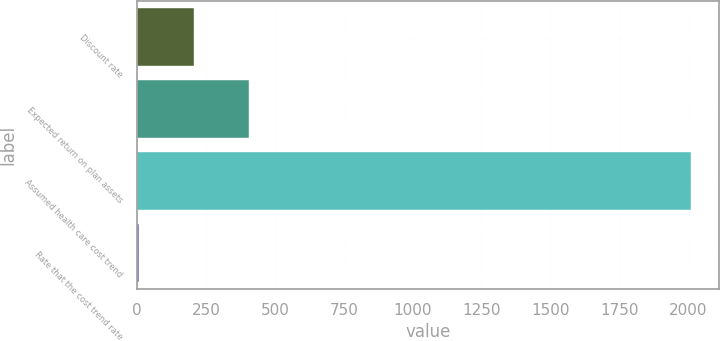Convert chart. <chart><loc_0><loc_0><loc_500><loc_500><bar_chart><fcel>Discount rate<fcel>Expected return on plan assets<fcel>Assumed health care cost trend<fcel>Rate that the cost trend rate<nl><fcel>205.6<fcel>406.2<fcel>2011<fcel>5<nl></chart> 